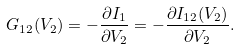<formula> <loc_0><loc_0><loc_500><loc_500>G _ { 1 2 } ( V _ { 2 } ) = - \frac { \partial I _ { 1 } } { \partial V _ { 2 } } = - \frac { \partial I _ { 1 2 } ( V _ { 2 } ) } { \partial V _ { 2 } } .</formula> 